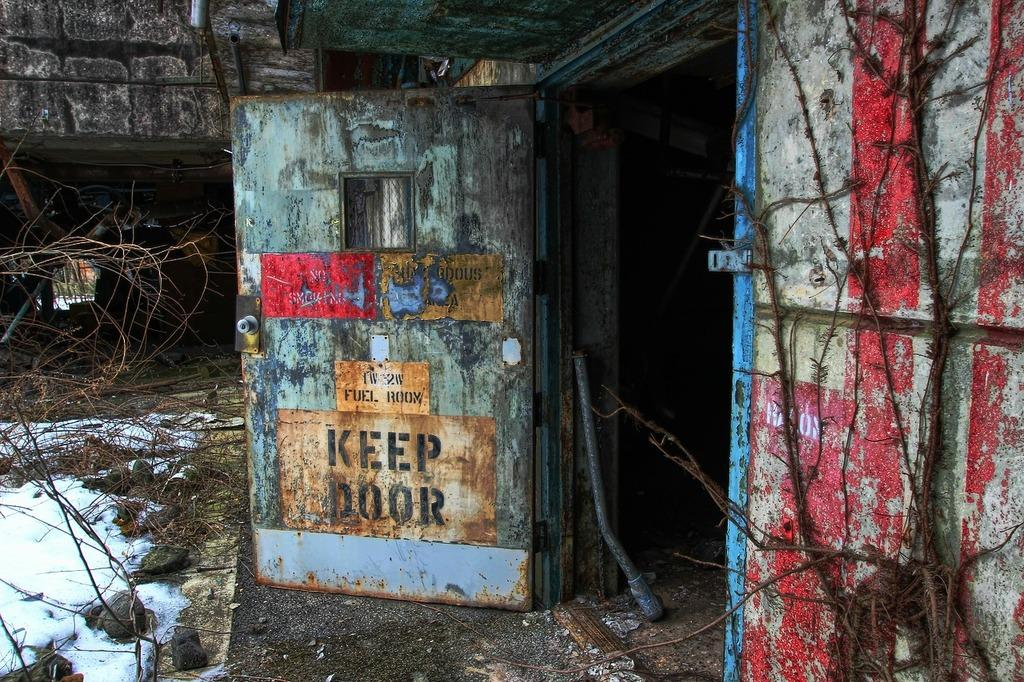What is one of the main features of the image? There is a door in the image. Where is the door located? The door is attached to a wall. What can be seen near the door? There is a rod near the door. What is present on the ground in the image? There are sticks and stones on the ground in the image. What type of stamp can be seen on the door in the image? There is no stamp present on the door in the image. What time of day is depicted in the image? The provided facts do not give any information about the time of day, so it cannot be determined from the image. 